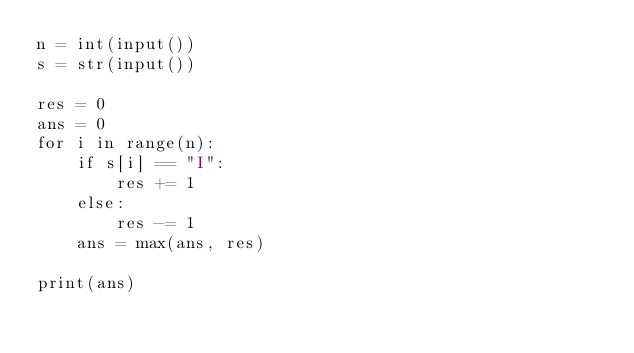Convert code to text. <code><loc_0><loc_0><loc_500><loc_500><_Python_>n = int(input())
s = str(input())

res = 0
ans = 0
for i in range(n):
    if s[i] == "I":
        res += 1
    else:
        res -= 1
    ans = max(ans, res)

print(ans)</code> 